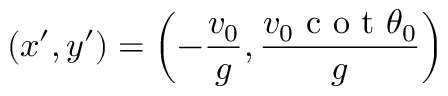<formula> <loc_0><loc_0><loc_500><loc_500>( x ^ { \prime } , y ^ { \prime } ) = \left ( - \frac { v _ { 0 } } { g } , \frac { v _ { 0 } c o t \theta _ { 0 } } { g } \right )</formula> 